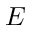Convert formula to latex. <formula><loc_0><loc_0><loc_500><loc_500>E</formula> 